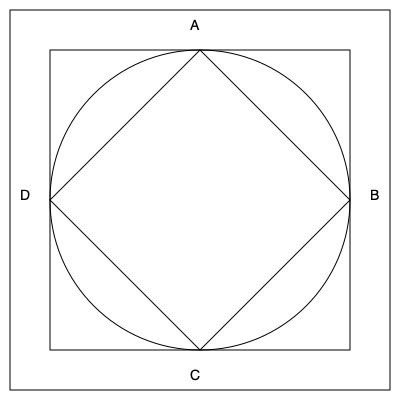The floor plans of four famous mosques are represented by basic geometric shapes in the diagram above. Which shape corresponds to the floor plan of the Great Mosque of Kairouan, known for its square design with a large courtyard? To answer this question, let's analyze each shape and its corresponding mosque design:

1. Shape A (Circle): This represents a circular or domed mosque design, which is not typical for the Great Mosque of Kairouan.

2. Shape B (Square): This represents a square floor plan, which is characteristic of many traditional mosques, including the Great Mosque of Kairouan.

3. Shape C (Octagon): This represents an octagonal floor plan, which is not common for large congregational mosques like the one in Kairouan.

4. Shape D (Diamond): This represents a diamond-shaped floor plan, which is not typical for traditional Islamic architecture.

The Great Mosque of Kairouan, located in Tunisia, is known for its square design with a large courtyard. It follows a traditional hypostyle plan, which is essentially a large square or rectangular space filled with columns supporting the roof.

Given this information, the shape that best represents the floor plan of the Great Mosque of Kairouan is the square (Shape B).
Answer: B (Square) 